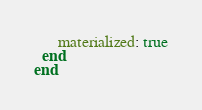Convert code to text. <code><loc_0><loc_0><loc_500><loc_500><_Ruby_>      materialized: true
  end
end
</code> 